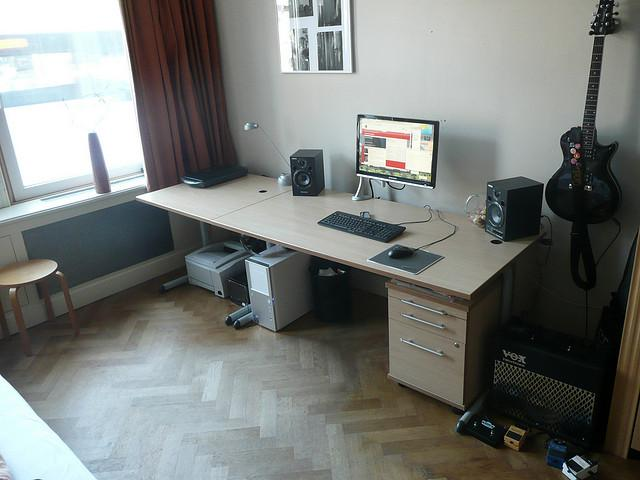What is the device on the floor under the desk near the wall?

Choices:
A) speaker
B) fax machine
C) computer tower
D) printer printer 